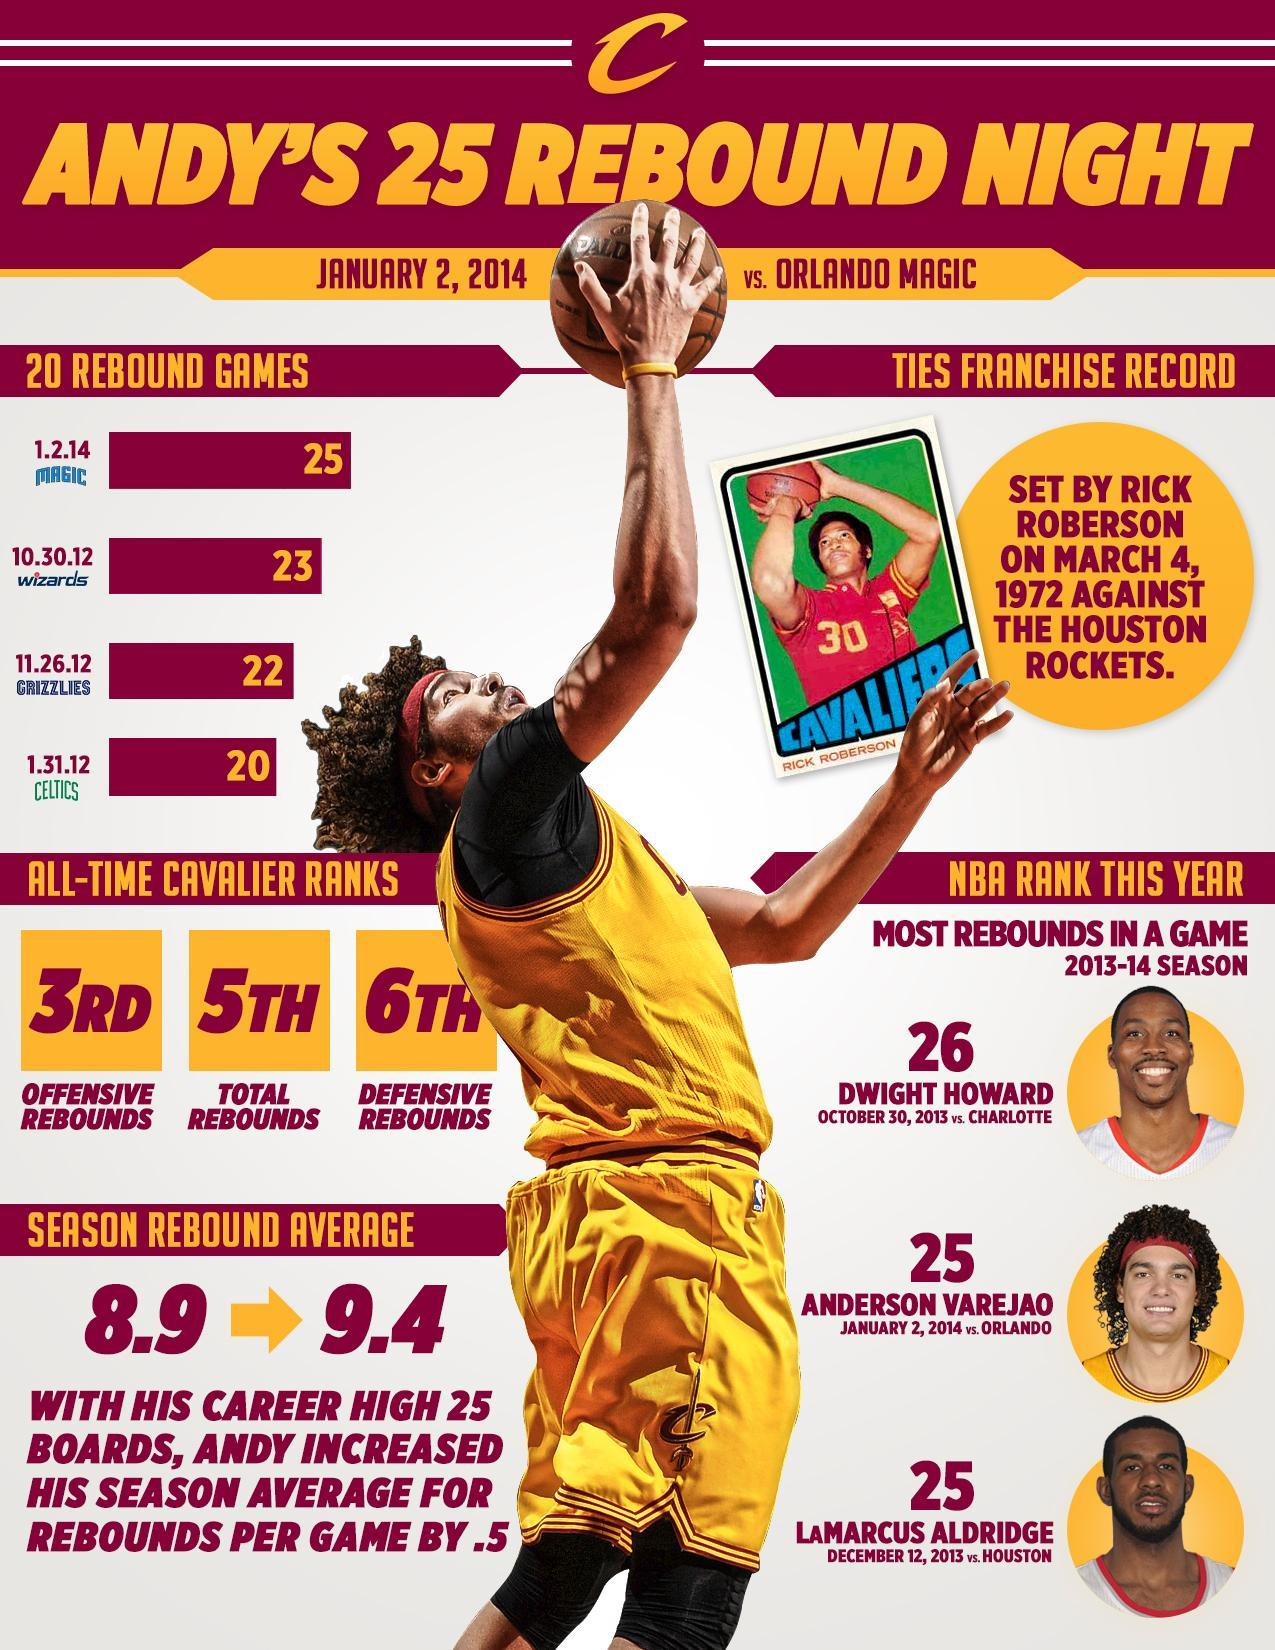WHo is ranked 25 in the most rebounds in a game in 2013-14 season
Answer the question with a short phrase. Anderson Varejao, LaMarcus Aldridge What is the number written on the jerysey of Rick Roberson 30 How many 20 rebound games in 2012 3 Against who were the 20 rebound games played against Wizards, Grizzlies, Celtics What is the All-time cavalier ranks for defensive rebounds 6th What is the jersey colour of Rick Roberson, red or yellow red What is the All-time cavalier ranks for total rebounds 5th 